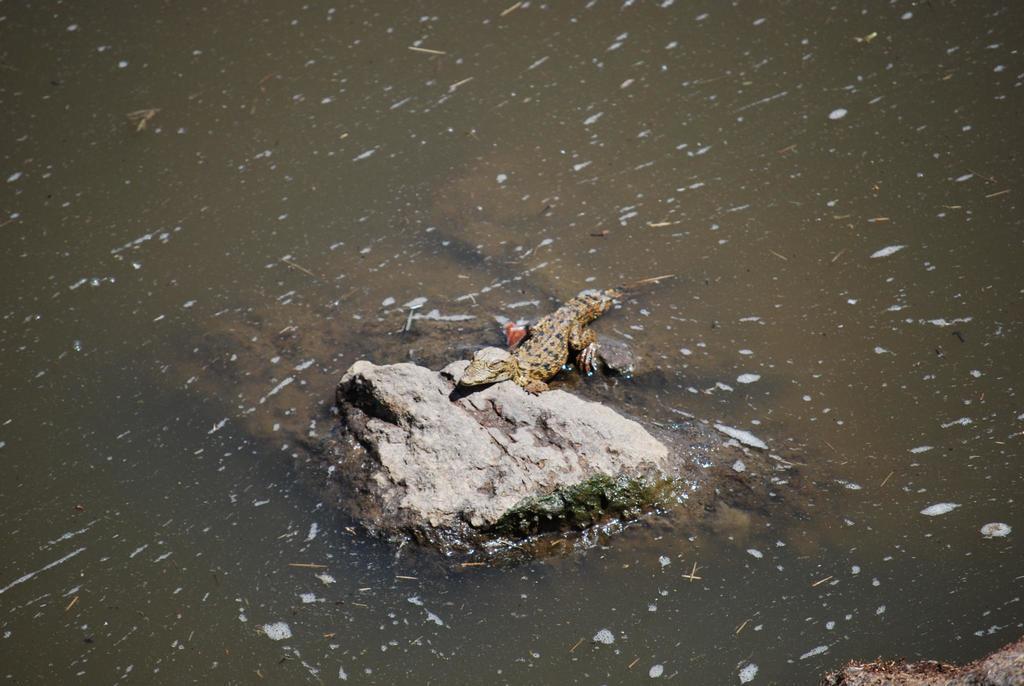Could you give a brief overview of what you see in this image? In this image I can see a crocodile on the stone. We can see water. Crocodile is in brown color. 